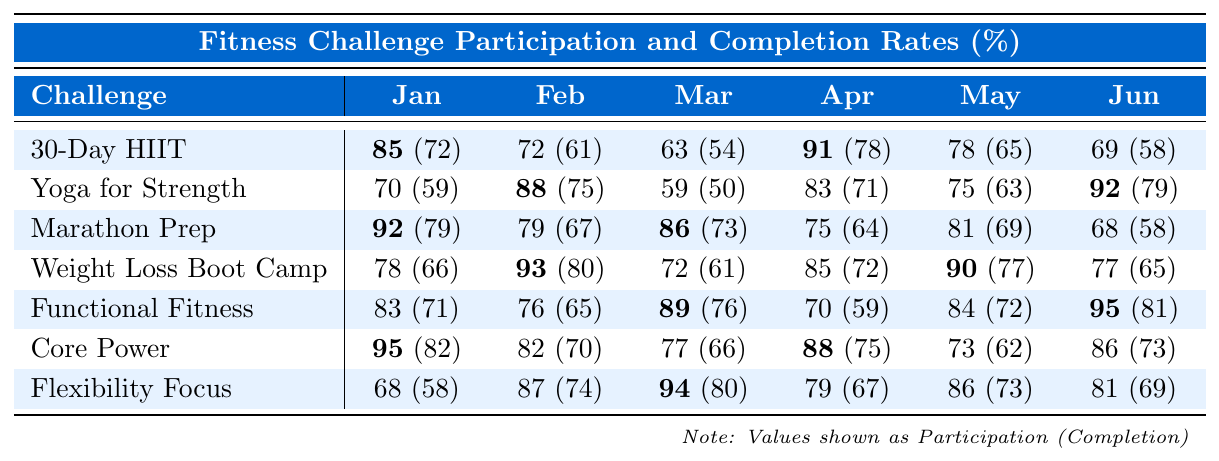What is the participation rate of the "Core Power Challenge" in April? The participation rate for the "Core Power Challenge" in April can be found in the table, which shows a value of 88%.
Answer: 88% What is the highest completion rate for any fitness challenge during any month? Looking through all the completion rates in the table, the highest value is 82% for the "Core Power Challenge" in January.
Answer: 82% What is the average participation rate for the "Functional Fitness Series"? The participation rates for the "Functional Fitness Series" across all months are 83, 76, 89, 70, 84, and 95. Adding these rates gives 83 + 76 + 89 + 70 + 84 + 95 = 497. Dividing by 6 months, the average is 497 / 6 = approximately 82.83%.
Answer: 82.83% Did the "Weight Loss Boot Camp" have a higher participation rate in February or March? The participation rate for "Weight Loss Boot Camp" in February is 93%, while in March it is 72%. Since 93% is higher than 72%, February had the higher rate.
Answer: Yes Which challenge has the lowest completion rate in May? Checking the completion rates for May across all challenges reveals that the lowest is 62% for the "Core Power Challenge."
Answer: 62% What is the difference between the participation rate and completion rate for the "Yoga for Strength" in June? For "Yoga for Strength" in June, the participation rate is 92% and the completion rate is 79%. The difference is calculated as 92 - 79 = 13%.
Answer: 13% Which month saw the highest overall participation rate across all challenges? To find the highest overall participation rate, add participation rates for each month, which gives: January (85+70+92+78+83+95+68 = 471), February (72+88+79+93+76+82+87 = 511), March (63+59+86+72+89+77+94 = 540), April (91+83+75+85+70+88+79 = 511), May (78+75+81+90+84+73+86 = 467), June (69+92+68+77+95+86+81 = 568). June has the highest total, 568.
Answer: June How many challenges had a completion rate above 70% in January? Looking at January's completion rates for each challenge: 72% (30-Day HIIT Challenge), 59% (Yoga for Strength), 79% (Marathon Prep), 66% (Weight Loss Boot Camp), 71% (Functional Fitness), 82% (Core Power), and 58% (Flexibility Focus). Four challenges have rates above 70%: 72%, 79%, 71%, and 82%.
Answer: 4 What is the average completion rate for "Flexibility Focus Month"? The completion rates for "Flexibility Focus Month" across all months are 58, 74, 80, 67, 73, and 69. Summing these gives 58 + 74 + 80 + 67 + 73 + 69 = 421. Dividing by the number of months (6), the average gives 421 / 6 = approximately 70.17%.
Answer: 70.17% 